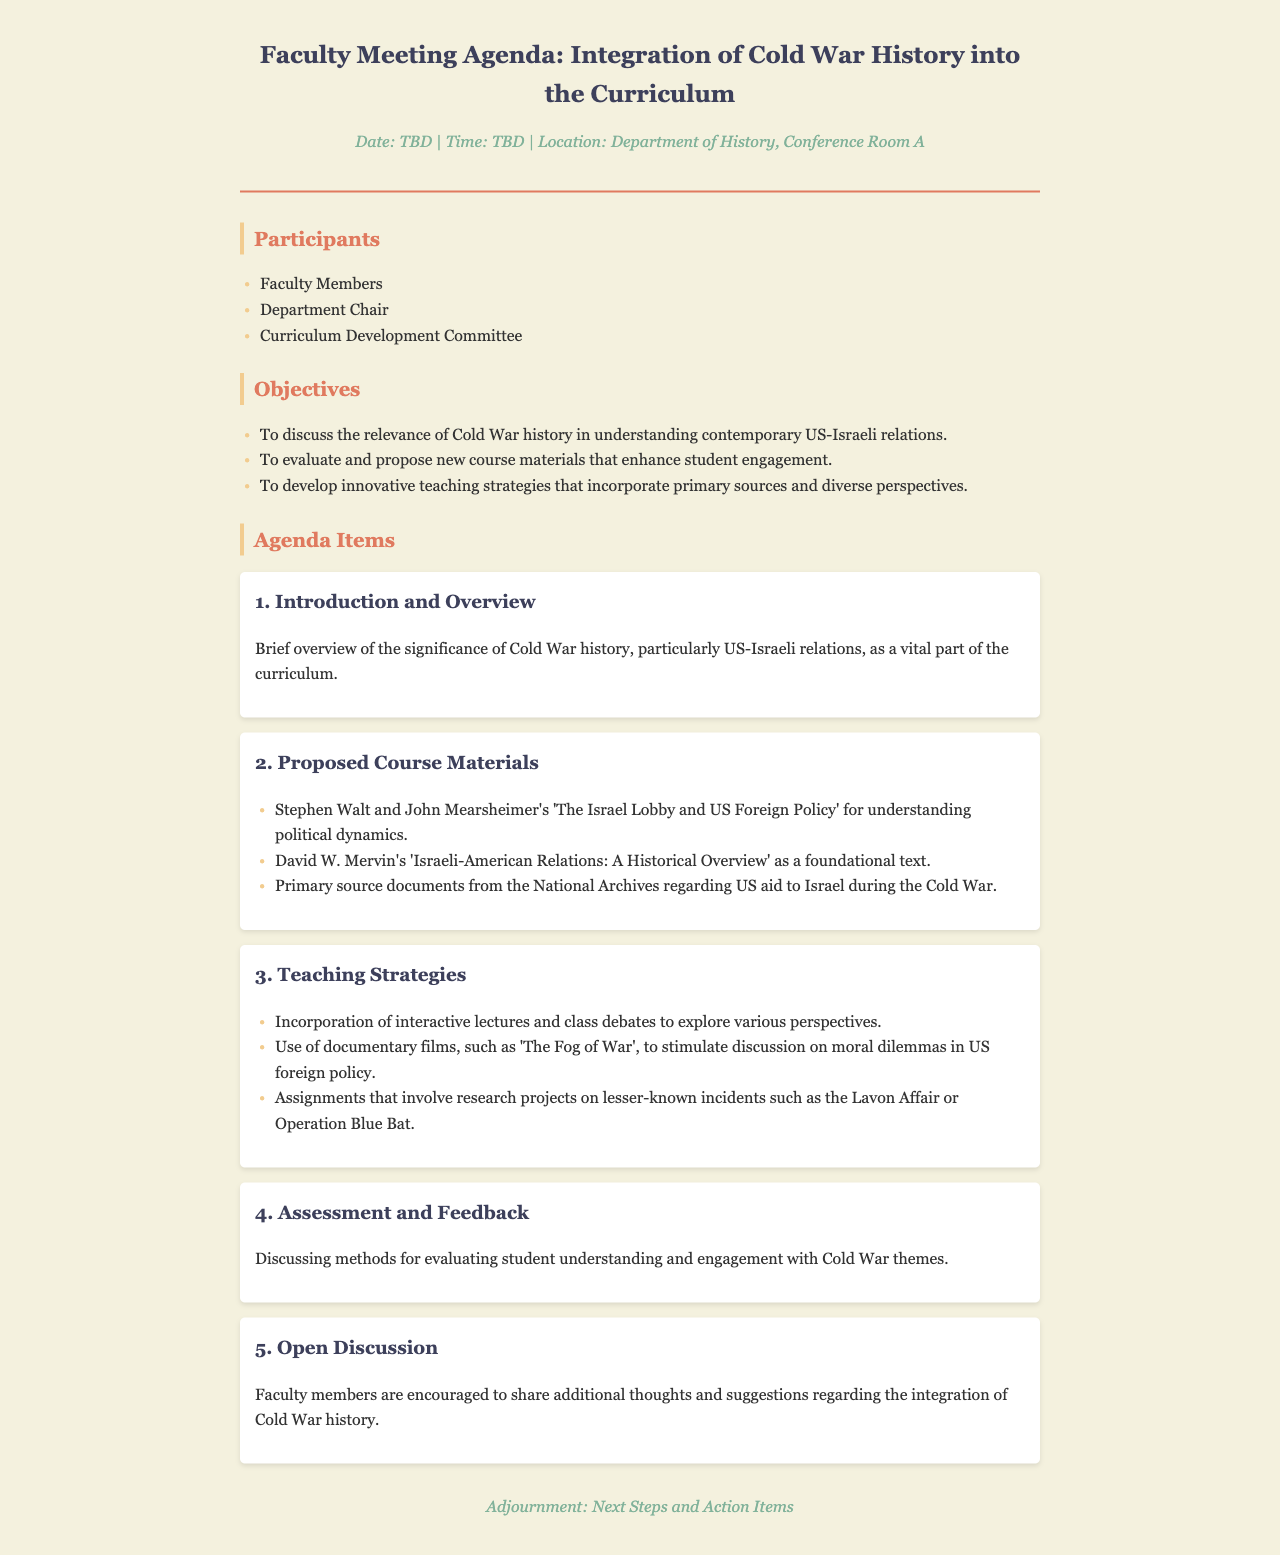What is the main topic of the meeting? The main topic of the meeting is the integration of Cold War history into the curriculum.
Answer: Integration of Cold War history What is the date of the meeting? The date of the meeting is listed as TBD.
Answer: TBD Who are the participants of the meeting? Participants include Faculty Members, Department Chair, and Curriculum Development Committee.
Answer: Faculty Members, Department Chair, Curriculum Development Committee What is one proposed course material? One proposed course material is 'The Israel Lobby and US Foreign Policy'.
Answer: The Israel Lobby and US Foreign Policy What is the focus of the teaching strategies discussed? The focus is on incorporating interactive lectures and diverse perspectives.
Answer: Interactive lectures and diverse perspectives What is discussed in the final agenda item? The final agenda item encourages an open discussion among faculty members.
Answer: Open Discussion How many agenda items are listed in total? Five agenda items are mentioned in the document.
Answer: Five What is the significance of Cold War history emphasized in the agenda? The significance emphasizes its relevance to contemporary US-Israeli relations.
Answer: Contemporary US-Israeli relations What is the purpose of the meeting? The purpose is to evaluate and propose new course materials for the curriculum.
Answer: Evaluate and propose new course materials 